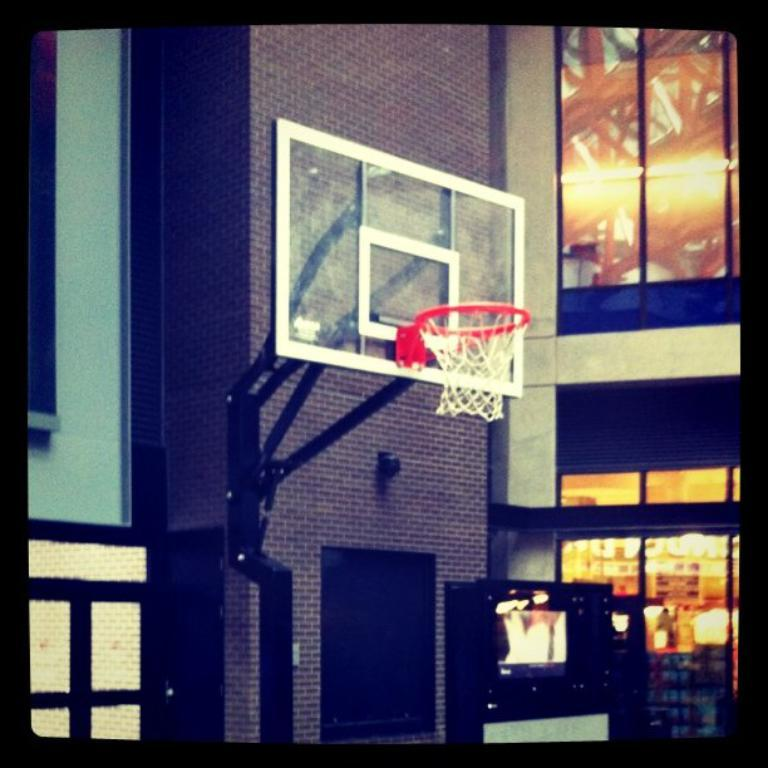What is the main object in the image? There is a goal post with a stand in the image. What type of structure can be seen in the background? There is a wall visible in the image. What electronic device is present in the image? There is a television in the image. What architectural feature allows natural light to enter the space? There are windows in the image. What type of owl can be seen perched on the goal post in the image? There is no owl present in the image; it only features a goal post with a stand, a wall, a television, and windows. 